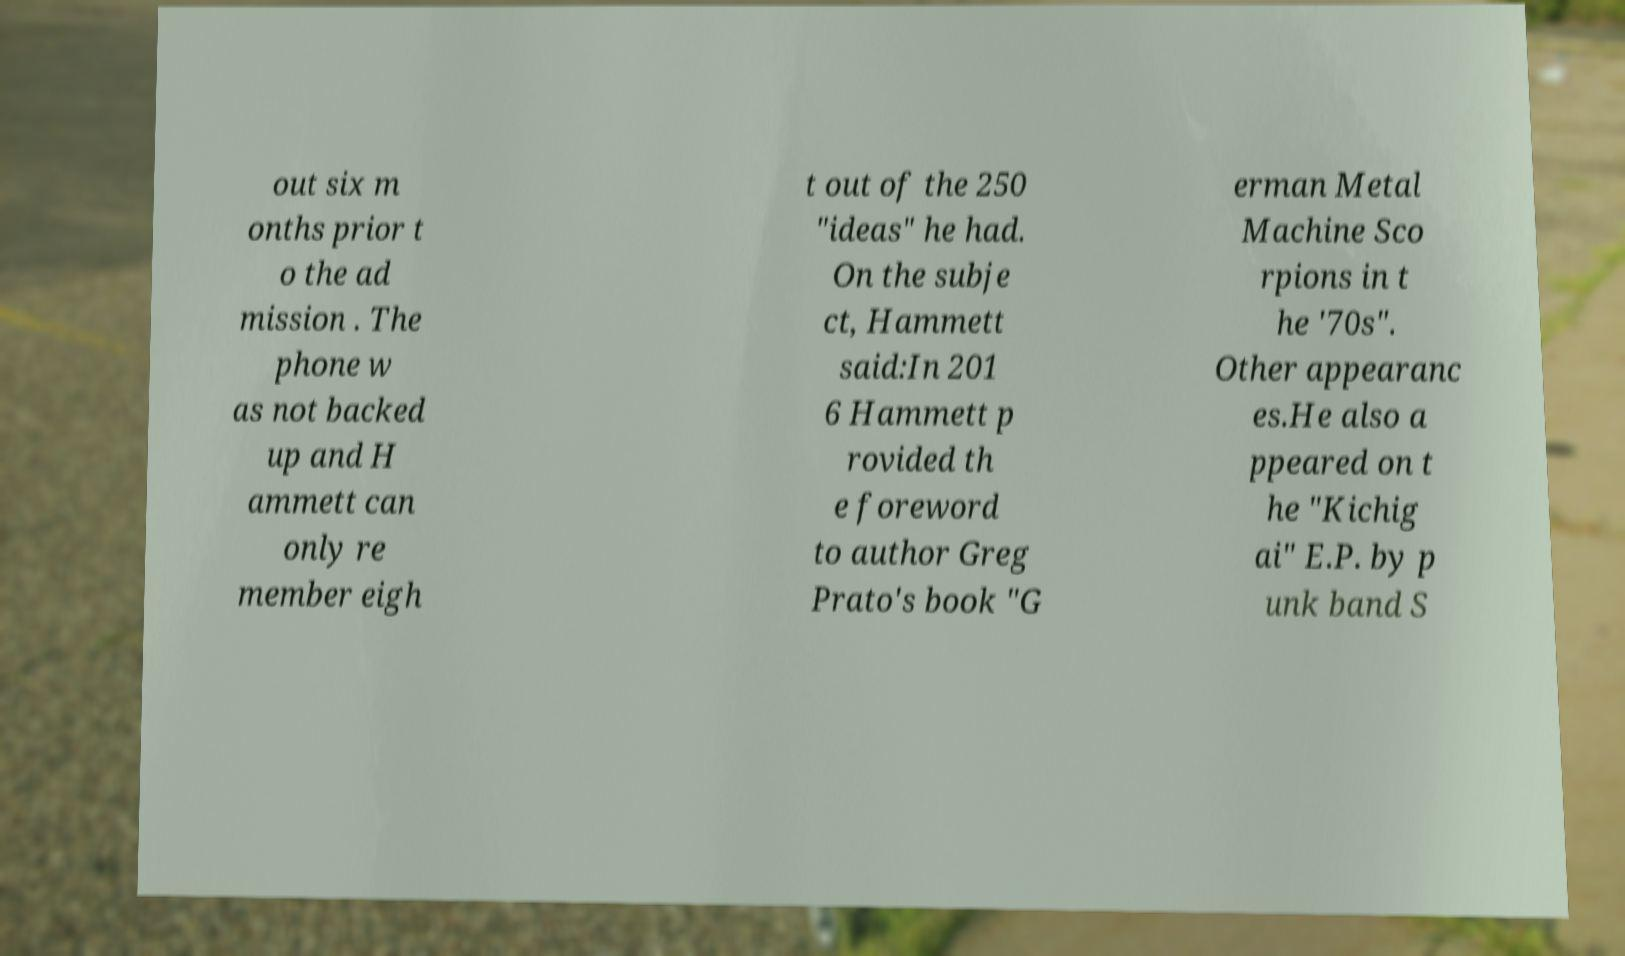Please read and relay the text visible in this image. What does it say? out six m onths prior t o the ad mission . The phone w as not backed up and H ammett can only re member eigh t out of the 250 "ideas" he had. On the subje ct, Hammett said:In 201 6 Hammett p rovided th e foreword to author Greg Prato's book "G erman Metal Machine Sco rpions in t he '70s". Other appearanc es.He also a ppeared on t he "Kichig ai" E.P. by p unk band S 